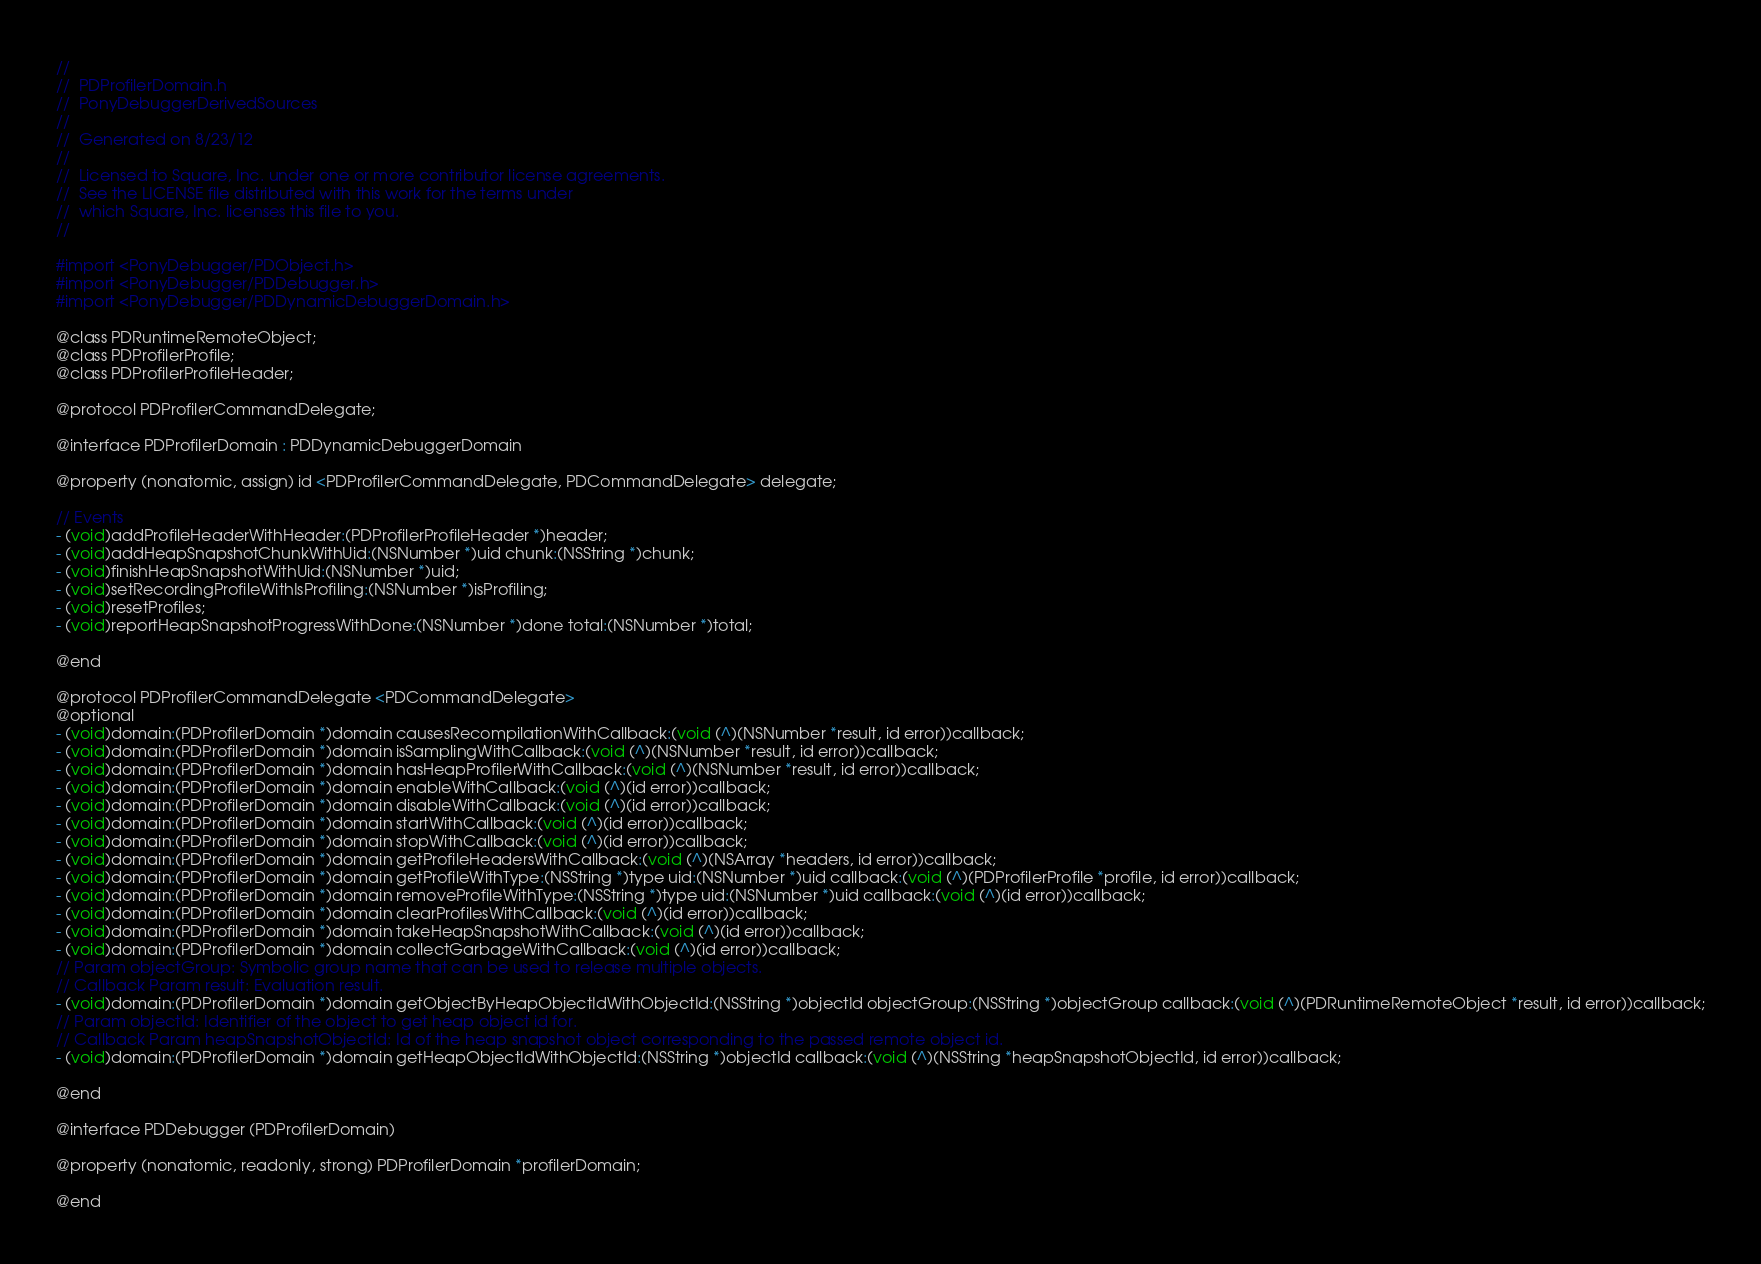<code> <loc_0><loc_0><loc_500><loc_500><_C_>//
//  PDProfilerDomain.h
//  PonyDebuggerDerivedSources
//
//  Generated on 8/23/12
//
//  Licensed to Square, Inc. under one or more contributor license agreements.
//  See the LICENSE file distributed with this work for the terms under
//  which Square, Inc. licenses this file to you.
//

#import <PonyDebugger/PDObject.h>
#import <PonyDebugger/PDDebugger.h>
#import <PonyDebugger/PDDynamicDebuggerDomain.h>

@class PDRuntimeRemoteObject;
@class PDProfilerProfile;
@class PDProfilerProfileHeader;

@protocol PDProfilerCommandDelegate;

@interface PDProfilerDomain : PDDynamicDebuggerDomain 

@property (nonatomic, assign) id <PDProfilerCommandDelegate, PDCommandDelegate> delegate;

// Events
- (void)addProfileHeaderWithHeader:(PDProfilerProfileHeader *)header;
- (void)addHeapSnapshotChunkWithUid:(NSNumber *)uid chunk:(NSString *)chunk;
- (void)finishHeapSnapshotWithUid:(NSNumber *)uid;
- (void)setRecordingProfileWithIsProfiling:(NSNumber *)isProfiling;
- (void)resetProfiles;
- (void)reportHeapSnapshotProgressWithDone:(NSNumber *)done total:(NSNumber *)total;

@end

@protocol PDProfilerCommandDelegate <PDCommandDelegate>
@optional
- (void)domain:(PDProfilerDomain *)domain causesRecompilationWithCallback:(void (^)(NSNumber *result, id error))callback;
- (void)domain:(PDProfilerDomain *)domain isSamplingWithCallback:(void (^)(NSNumber *result, id error))callback;
- (void)domain:(PDProfilerDomain *)domain hasHeapProfilerWithCallback:(void (^)(NSNumber *result, id error))callback;
- (void)domain:(PDProfilerDomain *)domain enableWithCallback:(void (^)(id error))callback;
- (void)domain:(PDProfilerDomain *)domain disableWithCallback:(void (^)(id error))callback;
- (void)domain:(PDProfilerDomain *)domain startWithCallback:(void (^)(id error))callback;
- (void)domain:(PDProfilerDomain *)domain stopWithCallback:(void (^)(id error))callback;
- (void)domain:(PDProfilerDomain *)domain getProfileHeadersWithCallback:(void (^)(NSArray *headers, id error))callback;
- (void)domain:(PDProfilerDomain *)domain getProfileWithType:(NSString *)type uid:(NSNumber *)uid callback:(void (^)(PDProfilerProfile *profile, id error))callback;
- (void)domain:(PDProfilerDomain *)domain removeProfileWithType:(NSString *)type uid:(NSNumber *)uid callback:(void (^)(id error))callback;
- (void)domain:(PDProfilerDomain *)domain clearProfilesWithCallback:(void (^)(id error))callback;
- (void)domain:(PDProfilerDomain *)domain takeHeapSnapshotWithCallback:(void (^)(id error))callback;
- (void)domain:(PDProfilerDomain *)domain collectGarbageWithCallback:(void (^)(id error))callback;
// Param objectGroup: Symbolic group name that can be used to release multiple objects.
// Callback Param result: Evaluation result.
- (void)domain:(PDProfilerDomain *)domain getObjectByHeapObjectIdWithObjectId:(NSString *)objectId objectGroup:(NSString *)objectGroup callback:(void (^)(PDRuntimeRemoteObject *result, id error))callback;
// Param objectId: Identifier of the object to get heap object id for.
// Callback Param heapSnapshotObjectId: Id of the heap snapshot object corresponding to the passed remote object id.
- (void)domain:(PDProfilerDomain *)domain getHeapObjectIdWithObjectId:(NSString *)objectId callback:(void (^)(NSString *heapSnapshotObjectId, id error))callback;

@end

@interface PDDebugger (PDProfilerDomain)

@property (nonatomic, readonly, strong) PDProfilerDomain *profilerDomain;

@end
</code> 